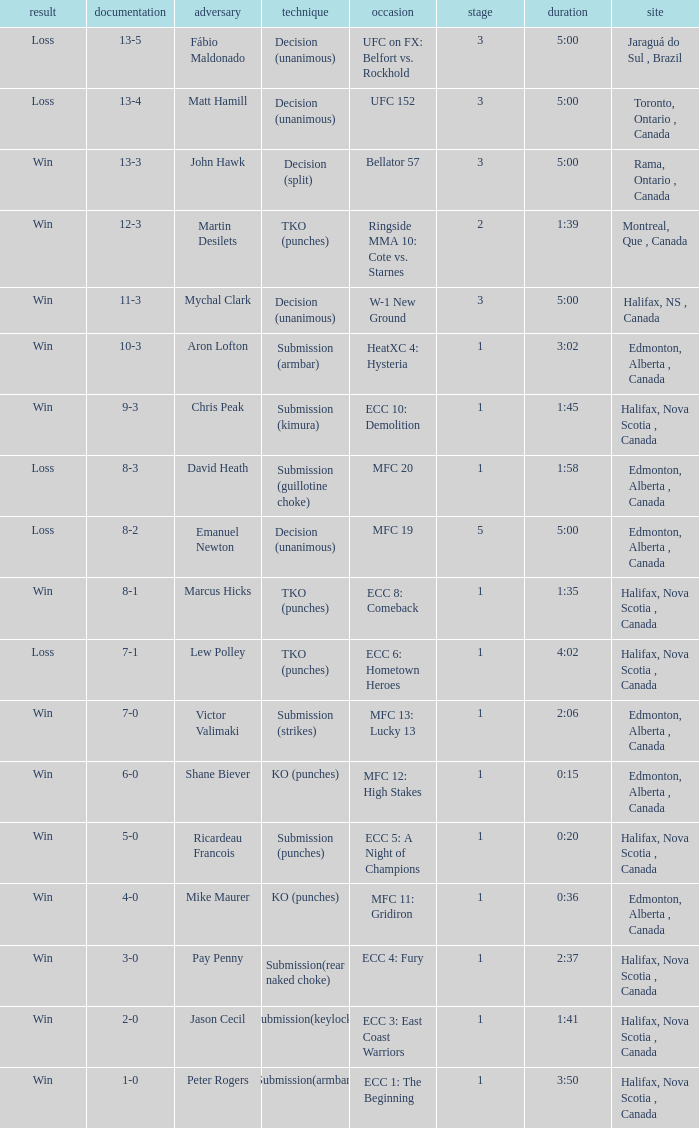What is the method of the match with 1 round and a time of 1:58? Submission (guillotine choke). 